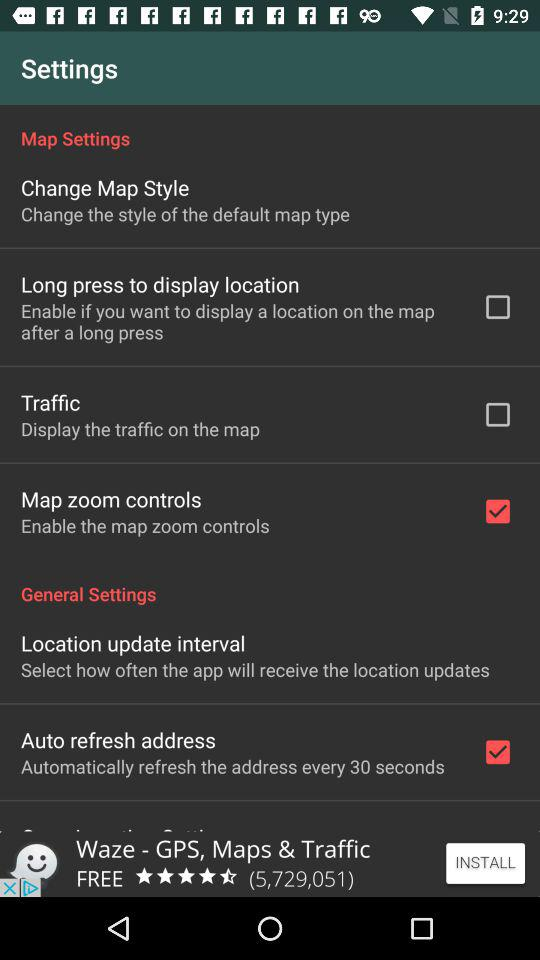Which option is disabled in the setting? The options disabled in the setting are "Long press to display location" and "Traffic". 